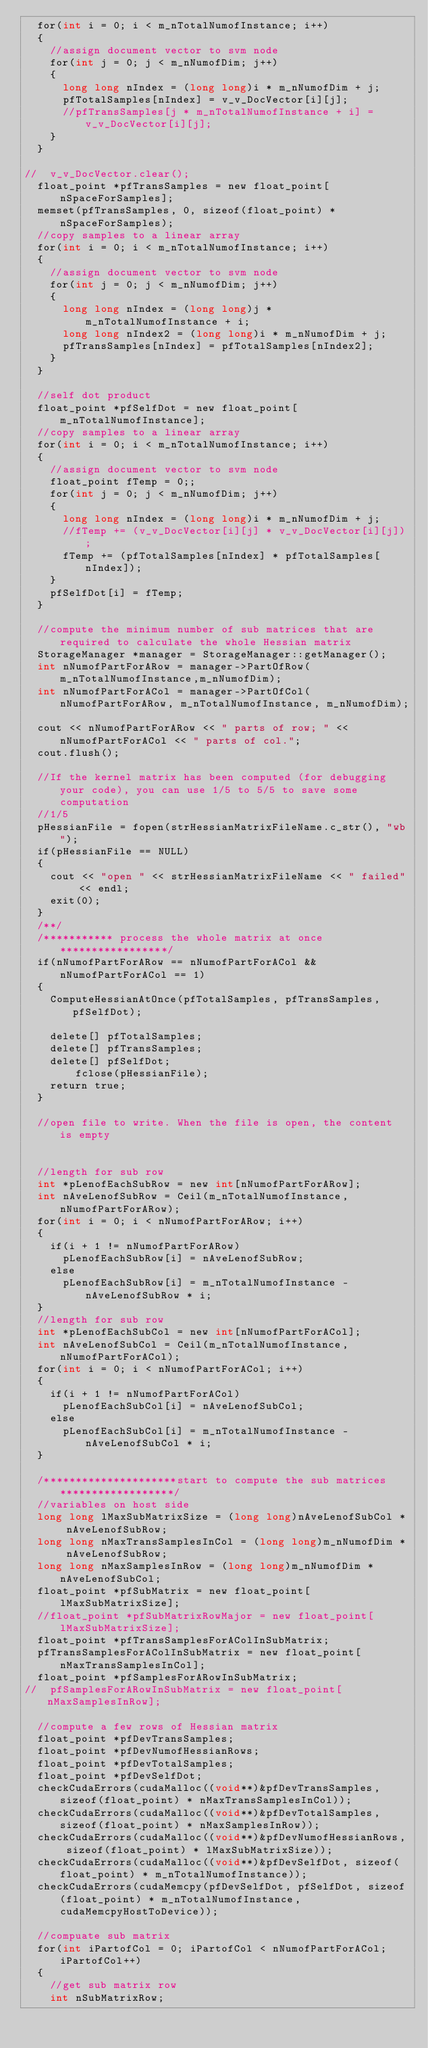Convert code to text. <code><loc_0><loc_0><loc_500><loc_500><_Cuda_>	for(int i = 0; i < m_nTotalNumofInstance; i++)
	{
		//assign document vector to svm node
		for(int j = 0; j < m_nNumofDim; j++)
		{
			long long nIndex = (long long)i * m_nNumofDim + j;
			pfTotalSamples[nIndex] = v_v_DocVector[i][j];
			//pfTransSamples[j * m_nTotalNumofInstance + i] = v_v_DocVector[i][j];
		}
	}

//	v_v_DocVector.clear();
	float_point *pfTransSamples = new float_point[nSpaceForSamples];
	memset(pfTransSamples, 0, sizeof(float_point) * nSpaceForSamples);
	//copy samples to a linear array
	for(int i = 0; i < m_nTotalNumofInstance; i++)
	{
		//assign document vector to svm node
		for(int j = 0; j < m_nNumofDim; j++)
		{
			long long nIndex = (long long)j * m_nTotalNumofInstance + i;
			long long nIndex2 = (long long)i * m_nNumofDim + j;
			pfTransSamples[nIndex] = pfTotalSamples[nIndex2];
		}
	}

	//self dot product
	float_point *pfSelfDot = new float_point[m_nTotalNumofInstance];
	//copy samples to a linear array
	for(int i = 0; i < m_nTotalNumofInstance; i++)
	{
		//assign document vector to svm node
		float_point fTemp = 0;;
		for(int j = 0; j < m_nNumofDim; j++)
		{
			long long nIndex = (long long)i * m_nNumofDim + j;
			//fTemp += (v_v_DocVector[i][j] * v_v_DocVector[i][j]);
			fTemp += (pfTotalSamples[nIndex] * pfTotalSamples[nIndex]);
		}
		pfSelfDot[i] = fTemp;
	}

	//compute the minimum number of sub matrices that are required to calculate the whole Hessian matrix
	StorageManager *manager = StorageManager::getManager();
	int nNumofPartForARow = manager->PartOfRow(m_nTotalNumofInstance,m_nNumofDim);
	int nNumofPartForACol = manager->PartOfCol(nNumofPartForARow, m_nTotalNumofInstance, m_nNumofDim);

	cout << nNumofPartForARow << " parts of row; " << nNumofPartForACol << " parts of col.";
	cout.flush();

	//If the kernel matrix has been computed (for debugging your code), you can use 1/5 to 5/5 to save some computation
	//1/5
	pHessianFile = fopen(strHessianMatrixFileName.c_str(), "wb");
	if(pHessianFile == NULL)
	{
		cout << "open " << strHessianMatrixFileName << " failed" << endl;
		exit(0);
	}
	/**/
	/*********** process the whole matrix at once *****************/
	if(nNumofPartForARow == nNumofPartForACol && nNumofPartForACol == 1)
	{
		ComputeHessianAtOnce(pfTotalSamples, pfTransSamples, pfSelfDot);

		delete[] pfTotalSamples;
		delete[] pfTransSamples;
		delete[] pfSelfDot;
        fclose(pHessianFile);
		return true;
	}

	//open file to write. When the file is open, the content is empty


	//length for sub row
	int *pLenofEachSubRow = new int[nNumofPartForARow];
	int nAveLenofSubRow = Ceil(m_nTotalNumofInstance, nNumofPartForARow);
	for(int i = 0; i < nNumofPartForARow; i++)
	{
		if(i + 1 != nNumofPartForARow)
			pLenofEachSubRow[i] = nAveLenofSubRow;
		else
			pLenofEachSubRow[i] = m_nTotalNumofInstance - nAveLenofSubRow * i;
	}
	//length for sub row
	int *pLenofEachSubCol = new int[nNumofPartForACol];
	int nAveLenofSubCol = Ceil(m_nTotalNumofInstance, nNumofPartForACol);
	for(int i = 0; i < nNumofPartForACol; i++)
	{
		if(i + 1 != nNumofPartForACol)
			pLenofEachSubCol[i] = nAveLenofSubCol;
		else
			pLenofEachSubCol[i] = m_nTotalNumofInstance - nAveLenofSubCol * i;
	}

	/*********************start to compute the sub matrices******************/
	//variables on host side
	long long lMaxSubMatrixSize = (long long)nAveLenofSubCol * nAveLenofSubRow;
	long long nMaxTransSamplesInCol = (long long)m_nNumofDim * nAveLenofSubRow;
	long long nMaxSamplesInRow = (long long)m_nNumofDim * nAveLenofSubCol;
	float_point *pfSubMatrix = new float_point[lMaxSubMatrixSize];
	//float_point *pfSubMatrixRowMajor = new float_point[lMaxSubMatrixSize];
	float_point *pfTransSamplesForAColInSubMatrix;
	pfTransSamplesForAColInSubMatrix = new float_point[nMaxTransSamplesInCol];
	float_point *pfSamplesForARowInSubMatrix;
//	pfSamplesForARowInSubMatrix = new float_point[nMaxSamplesInRow];

	//compute a few rows of Hessian matrix
	float_point *pfDevTransSamples;
	float_point *pfDevNumofHessianRows;
	float_point *pfDevTotalSamples;
	float_point *pfDevSelfDot;
	checkCudaErrors(cudaMalloc((void**)&pfDevTransSamples, sizeof(float_point) * nMaxTransSamplesInCol));
	checkCudaErrors(cudaMalloc((void**)&pfDevTotalSamples, sizeof(float_point) * nMaxSamplesInRow));
	checkCudaErrors(cudaMalloc((void**)&pfDevNumofHessianRows, sizeof(float_point) * lMaxSubMatrixSize));
	checkCudaErrors(cudaMalloc((void**)&pfDevSelfDot, sizeof(float_point) * m_nTotalNumofInstance));
	checkCudaErrors(cudaMemcpy(pfDevSelfDot, pfSelfDot, sizeof(float_point) * m_nTotalNumofInstance, cudaMemcpyHostToDevice));

	//compuate sub matrix
	for(int iPartofCol = 0; iPartofCol < nNumofPartForACol; iPartofCol++)
	{
		//get sub matrix row
		int nSubMatrixRow;</code> 